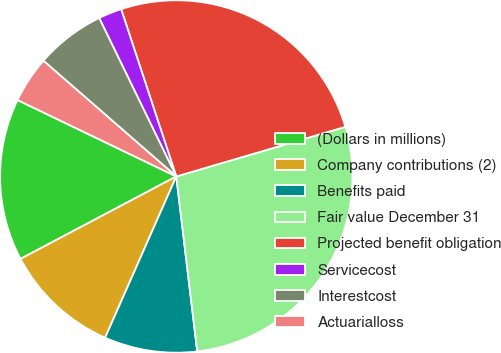Convert chart. <chart><loc_0><loc_0><loc_500><loc_500><pie_chart><fcel>(Dollars in millions)<fcel>Company contributions (2)<fcel>Benefits paid<fcel>Fair value December 31<fcel>Projected benefit obligation<fcel>Servicecost<fcel>Interestcost<fcel>Actuarialloss<nl><fcel>14.89%<fcel>10.64%<fcel>8.51%<fcel>27.65%<fcel>25.52%<fcel>2.14%<fcel>6.39%<fcel>4.26%<nl></chart> 